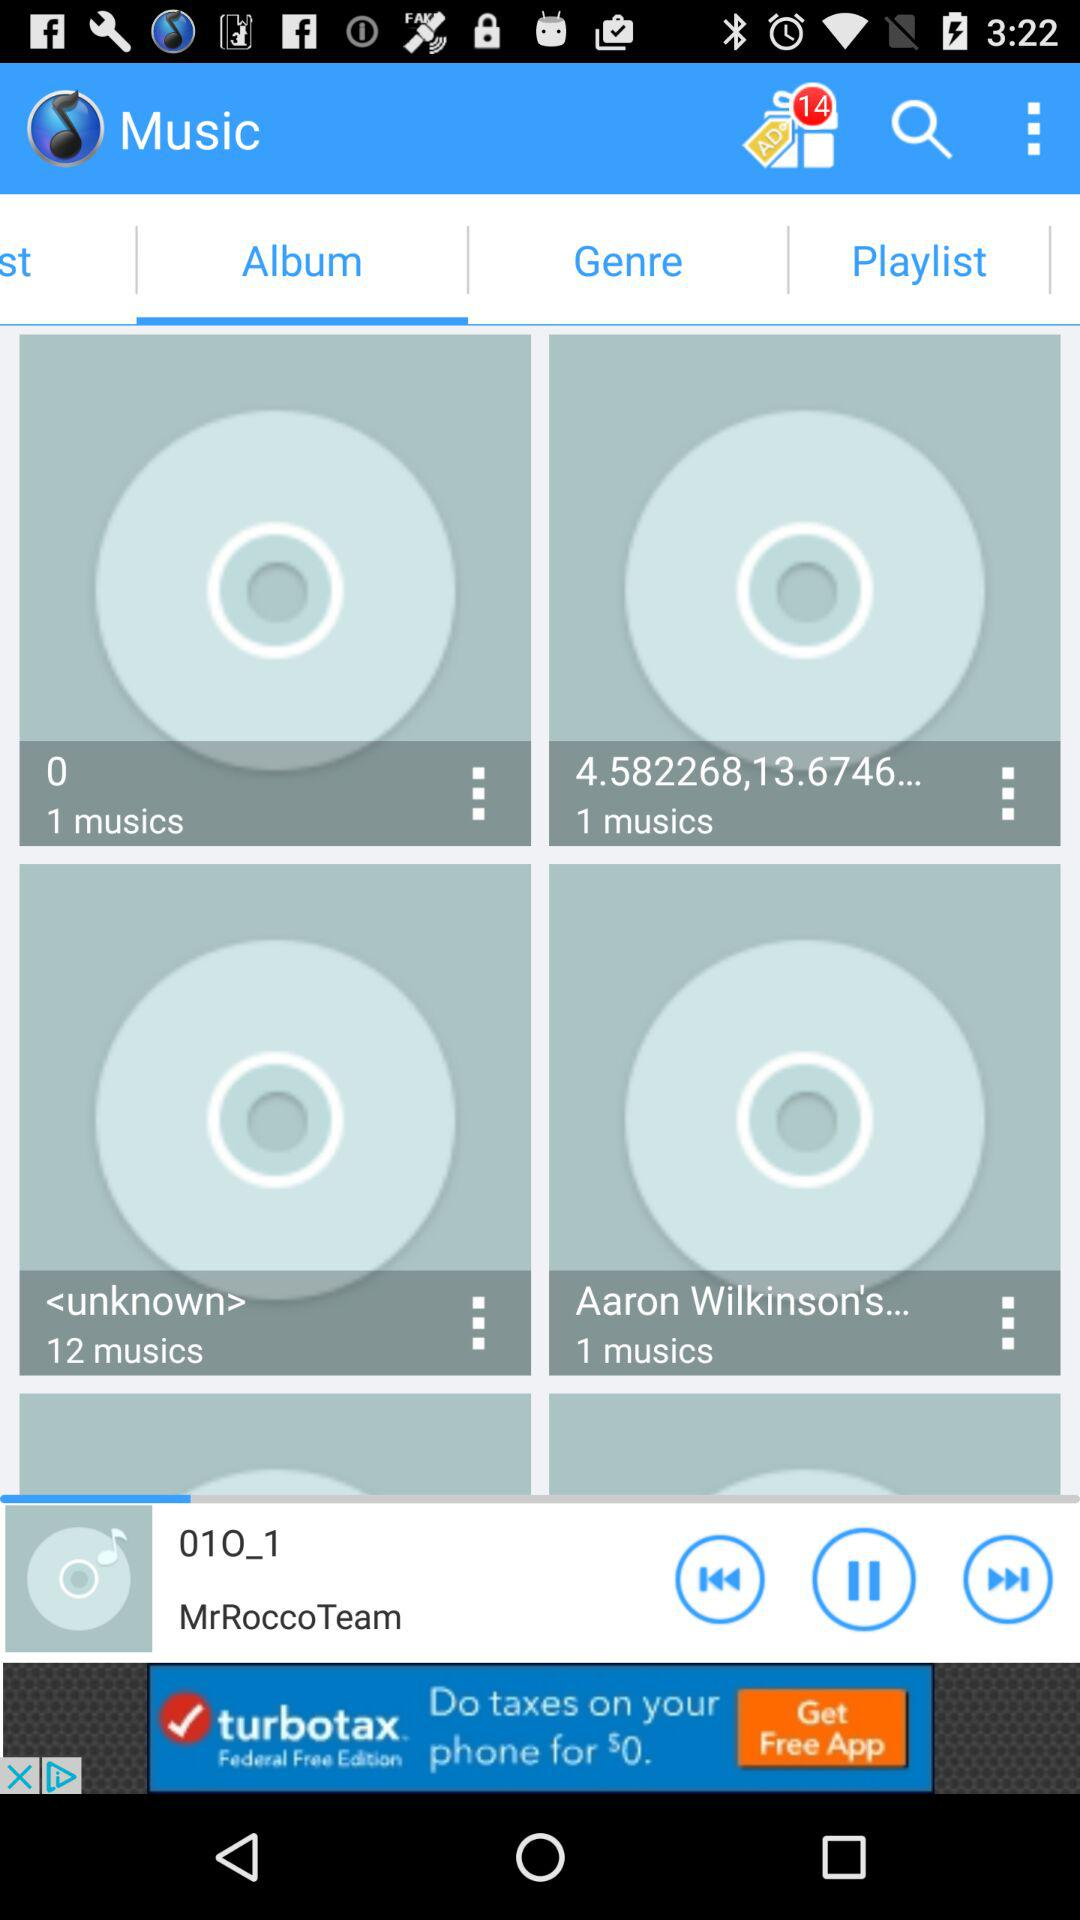How many musics are in the album 'Aaron Wilkinson's'?
Answer the question using a single word or phrase. 1 